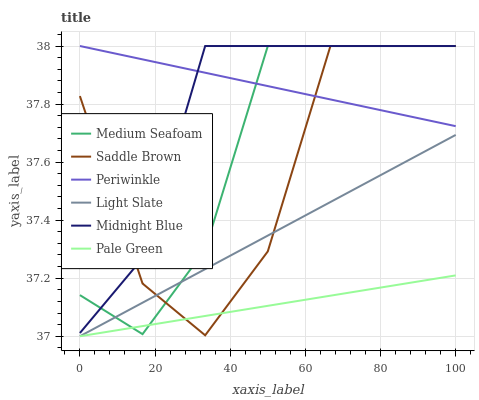Does Pale Green have the minimum area under the curve?
Answer yes or no. Yes. Does Periwinkle have the maximum area under the curve?
Answer yes or no. Yes. Does Light Slate have the minimum area under the curve?
Answer yes or no. No. Does Light Slate have the maximum area under the curve?
Answer yes or no. No. Is Periwinkle the smoothest?
Answer yes or no. Yes. Is Saddle Brown the roughest?
Answer yes or no. Yes. Is Light Slate the smoothest?
Answer yes or no. No. Is Light Slate the roughest?
Answer yes or no. No. Does Saddle Brown have the lowest value?
Answer yes or no. No. Does Light Slate have the highest value?
Answer yes or no. No. Is Pale Green less than Periwinkle?
Answer yes or no. Yes. Is Midnight Blue greater than Pale Green?
Answer yes or no. Yes. Does Pale Green intersect Periwinkle?
Answer yes or no. No. 